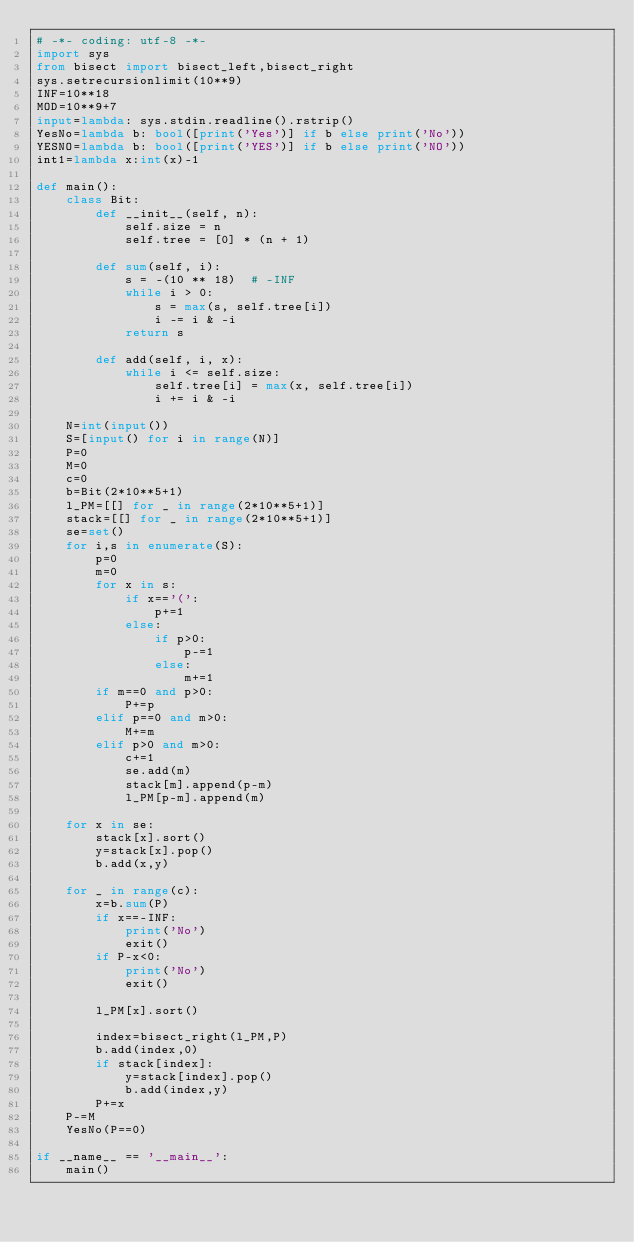<code> <loc_0><loc_0><loc_500><loc_500><_Python_># -*- coding: utf-8 -*-
import sys
from bisect import bisect_left,bisect_right
sys.setrecursionlimit(10**9)
INF=10**18
MOD=10**9+7
input=lambda: sys.stdin.readline().rstrip()
YesNo=lambda b: bool([print('Yes')] if b else print('No'))
YESNO=lambda b: bool([print('YES')] if b else print('NO'))
int1=lambda x:int(x)-1

def main():
    class Bit:
        def __init__(self, n):
            self.size = n
            self.tree = [0] * (n + 1)
    
        def sum(self, i):
            s = -(10 ** 18)  # -INF
            while i > 0:
                s = max(s, self.tree[i])
                i -= i & -i
            return s
    
        def add(self, i, x):
            while i <= self.size:
                self.tree[i] = max(x, self.tree[i])
                i += i & -i
    
    N=int(input())
    S=[input() for i in range(N)]
    P=0
    M=0
    c=0
    b=Bit(2*10**5+1)
    l_PM=[[] for _ in range(2*10**5+1)]
    stack=[[] for _ in range(2*10**5+1)]
    se=set()
    for i,s in enumerate(S):
        p=0
        m=0
        for x in s:
            if x=='(':
                p+=1
            else:
                if p>0:
                    p-=1
                else:
                    m+=1
        if m==0 and p>0:
            P+=p
        elif p==0 and m>0:
            M+=m
        elif p>0 and m>0:
            c+=1
            se.add(m)
            stack[m].append(p-m)
            l_PM[p-m].append(m)
    
    for x in se:
        stack[x].sort()
        y=stack[x].pop()
        b.add(x,y)
    
    for _ in range(c):
        x=b.sum(P)
        if x==-INF:
            print('No')
            exit()
        if P-x<0:
            print('No')
            exit()
        
        l_PM[x].sort()
        
        index=bisect_right(l_PM,P)
        b.add(index,0)
        if stack[index]:
            y=stack[index].pop()
            b.add(index,y)
        P+=x
    P-=M
    YesNo(P==0)

if __name__ == '__main__':
    main()
</code> 